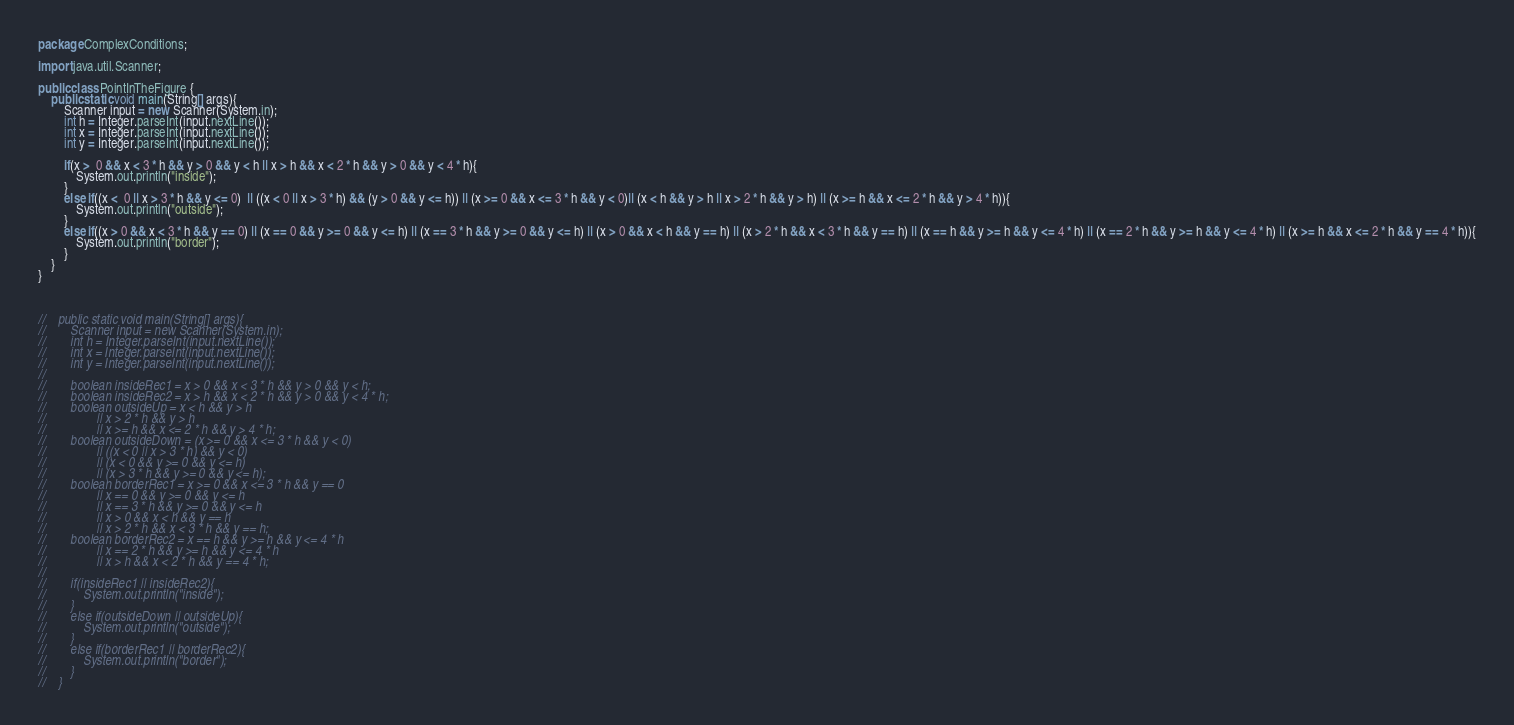Convert code to text. <code><loc_0><loc_0><loc_500><loc_500><_Java_>package ComplexConditions;

import java.util.Scanner;

public class PointInTheFigure {
    public static void main(String[] args){
        Scanner input = new Scanner(System.in);
        int h = Integer.parseInt(input.nextLine());
        int x = Integer.parseInt(input.nextLine());
        int y = Integer.parseInt(input.nextLine());

        if(x >  0 && x < 3 * h && y > 0 && y < h || x > h && x < 2 * h && y > 0 && y < 4 * h){
            System.out.println("inside");
        }
        else if((x <  0 || x > 3 * h && y <= 0)  || ((x < 0 || x > 3 * h) && (y > 0 && y <= h)) || (x >= 0 && x <= 3 * h && y < 0)|| (x < h && y > h || x > 2 * h && y > h) || (x >= h && x <= 2 * h && y > 4 * h)){
            System.out.println("outside");
        }
        else if((x > 0 && x < 3 * h && y == 0) || (x == 0 && y >= 0 && y <= h) || (x == 3 * h && y >= 0 && y <= h) || (x > 0 && x < h && y == h) || (x > 2 * h && x < 3 * h && y == h) || (x == h && y >= h && y <= 4 * h) || (x == 2 * h && y >= h && y <= 4 * h) || (x >= h && x <= 2 * h && y == 4 * h)){
            System.out.println("border");
        }
    }
}



//    public static void main(String[] args){
//        Scanner input = new Scanner(System.in);
//        int h = Integer.parseInt(input.nextLine());
//        int x = Integer.parseInt(input.nextLine());
//        int y = Integer.parseInt(input.nextLine());
//
//        boolean insideRec1 = x > 0 && x < 3 * h && y > 0 && y < h;
//        boolean insideRec2 = x > h && x < 2 * h && y > 0 && y < 4 * h;
//        boolean outsideUp = x < h && y > h
//                || x > 2 * h && y > h
//                || x >= h && x <= 2 * h && y > 4 * h;
//        boolean outsideDown = (x >= 0 && x <= 3 * h && y < 0)
//                || ((x < 0 || x > 3 * h) && y < 0)
//                || (x < 0 && y >= 0 && y <= h)
//                || (x > 3 * h && y >= 0 && y <= h);
//        boolean borderRec1 = x >= 0 && x <= 3 * h && y == 0
//                || x == 0 && y >= 0 && y <= h
//                || x == 3 * h && y >= 0 && y <= h
//                || x > 0 && x < h && y == h
//                || x > 2 * h && x < 3 * h && y == h;
//        boolean borderRec2 = x == h && y >= h && y <= 4 * h
//                || x == 2 * h && y >= h && y <= 4 * h
//                || x > h && x < 2 * h && y == 4 * h;
//
//        if(insideRec1 || insideRec2){
//            System.out.println("inside");
//        }
//        else if(outsideDown || outsideUp){
//            System.out.println("outside");
//        }
//        else if(borderRec1 || borderRec2){
//            System.out.println("border");
//        }
//    }</code> 